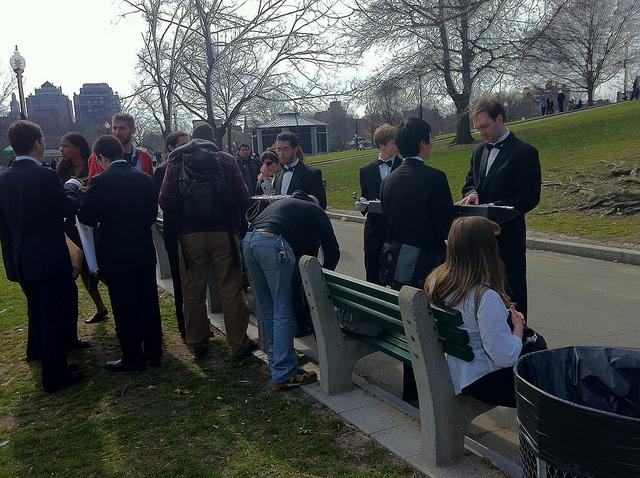What does the man farthest to the right have on his neck? Please explain your reasoning. bowtie. The man is wearing a bow like tie. 